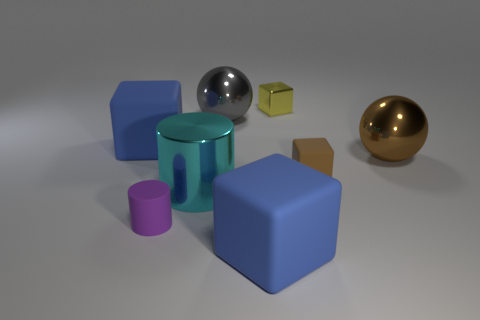Subtract 1 balls. How many balls are left? 1 Subtract all metal blocks. How many blocks are left? 3 Subtract all yellow cubes. How many cubes are left? 3 Subtract all brown spheres. Subtract all yellow cylinders. How many spheres are left? 1 Subtract all gray cubes. How many purple spheres are left? 0 Subtract all big blue matte objects. Subtract all large brown balls. How many objects are left? 5 Add 5 tiny blocks. How many tiny blocks are left? 7 Add 4 big blue rubber cylinders. How many big blue rubber cylinders exist? 4 Add 1 yellow metallic blocks. How many objects exist? 9 Subtract 0 yellow cylinders. How many objects are left? 8 